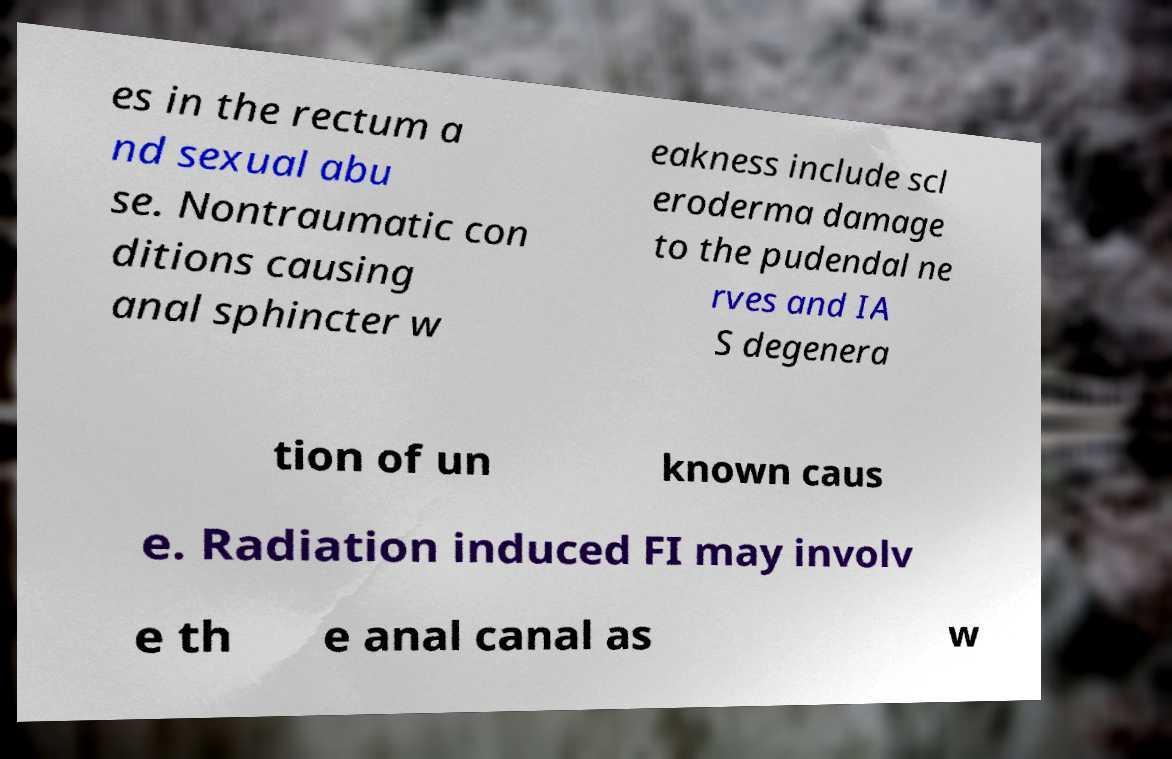Can you read and provide the text displayed in the image?This photo seems to have some interesting text. Can you extract and type it out for me? es in the rectum a nd sexual abu se. Nontraumatic con ditions causing anal sphincter w eakness include scl eroderma damage to the pudendal ne rves and IA S degenera tion of un known caus e. Radiation induced FI may involv e th e anal canal as w 